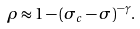<formula> <loc_0><loc_0><loc_500><loc_500>\rho \approx 1 - ( \sigma _ { c } - \sigma ) ^ { - \gamma } .</formula> 